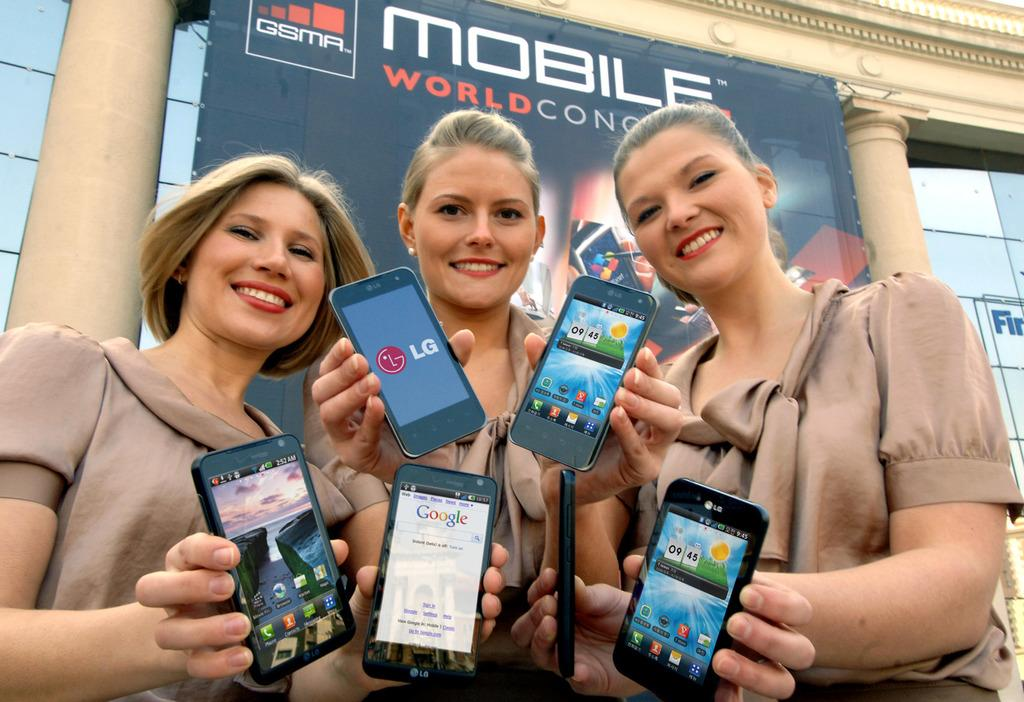<image>
Give a short and clear explanation of the subsequent image. Three girls holding up their devices in front of a sign that says Mobile World Con. 